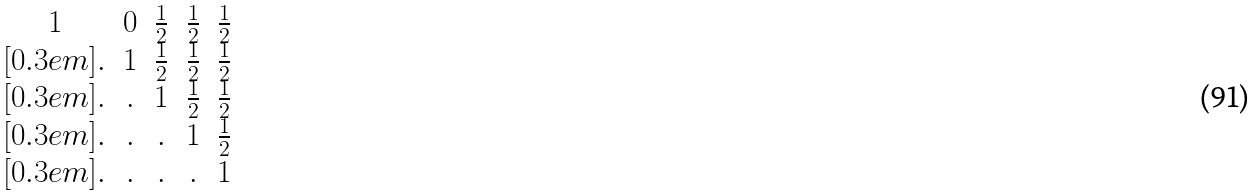<formula> <loc_0><loc_0><loc_500><loc_500>\begin{matrix} 1 & 0 & \frac { 1 } { 2 } & \frac { 1 } { 2 } & \frac { 1 } { 2 } \\ [ 0 . 3 e m ] . & 1 & \frac { 1 } { 2 } & \frac { 1 } { 2 } & \frac { 1 } { 2 } \\ [ 0 . 3 e m ] . & . & 1 & \frac { 1 } { 2 } & \frac { 1 } { 2 } \\ [ 0 . 3 e m ] . & . & . & 1 & \frac { 1 } { 2 } \\ [ 0 . 3 e m ] . & . & . & . & 1 \end{matrix}</formula> 